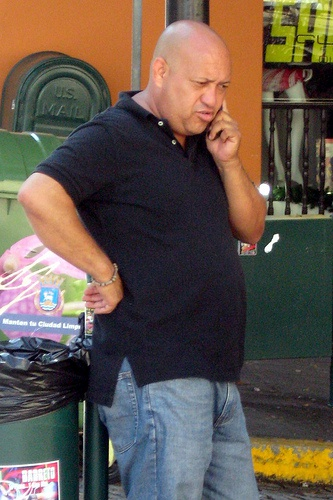Describe the objects in this image and their specific colors. I can see people in salmon, black, tan, and gray tones and cell phone in maroon, black, and salmon tones in this image. 